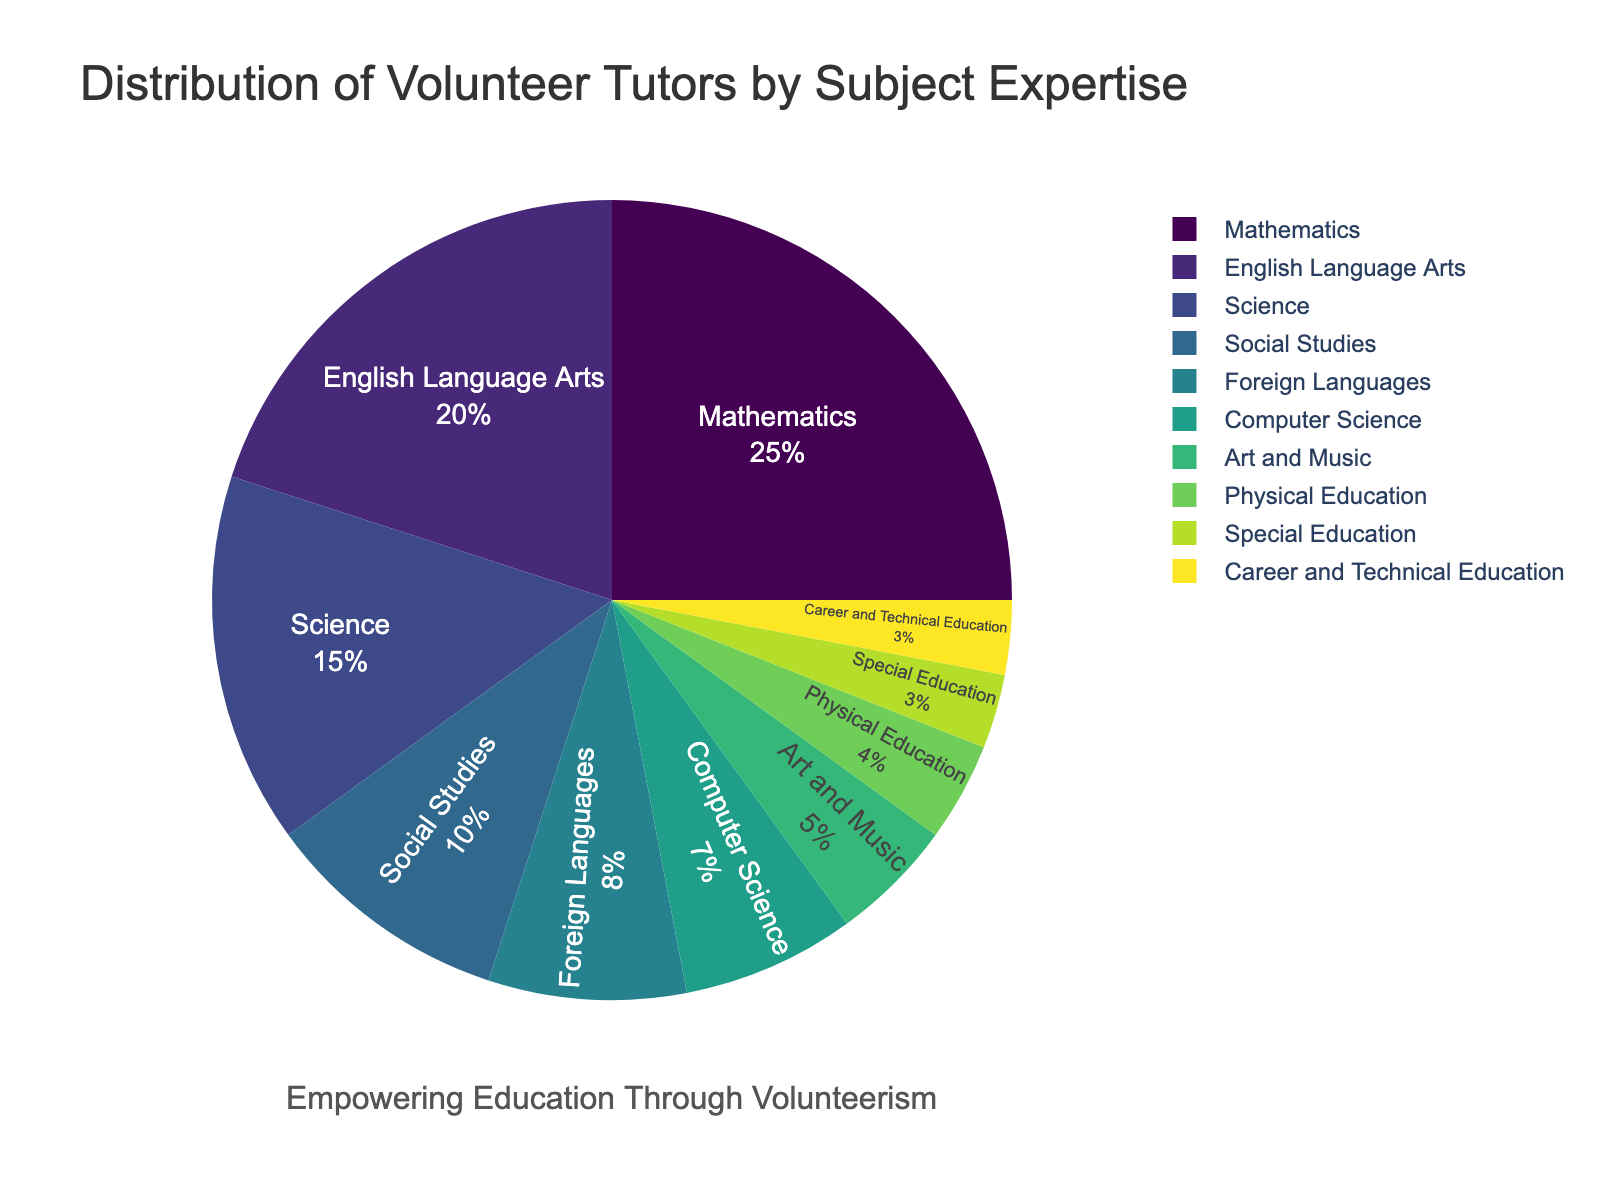What percentage of volunteer tutors specialize in Science and Computer Science combined? To find the combined percentage of Science and Computer Science, sum the individual percentages: 15% (Science) + 7% (Computer Science) = 22%.
Answer: 22% Which subject has the least number of volunteer tutors? Identify the subject with the smallest percentage value: Special Education and Career and Technical Education both have 3%, which is the lowest.
Answer: Special Education and Career and Technical Education How many subjects have a greater percentage of volunteer tutors than Foreign Languages? Compare the percentage of each subject to Foreign Languages (8%). Subjects with greater percentages are Mathematics (25%), English Language Arts (20%), and Science (15%), and Social Studies (10%). There are 4 subjects in total.
Answer: 4 Is the percentage of volunteer tutors in Mathematics more than double those in Art and Music? Double the percentage for Art and Music (5%) is 10%. Compare this with Mathematics (25%). Since 25% > 10%, Mathematics has more than double the percentage of Art and Music.
Answer: Yes Which two subjects have a combined percentage of exactly 25%? Look for pairs of subjects whose percentages sum to 25%. Foreign Languages (8%) and Computer Science (7%) combined is 15%, and Social Studies (10%) combined with Physical Education (4%) is 14%, none of these pairs work. However, Special Education (3%) and Career and Technical Education (3%) combined is 6%. There are no such pairs that exactly add to 25%.
Answer: None 